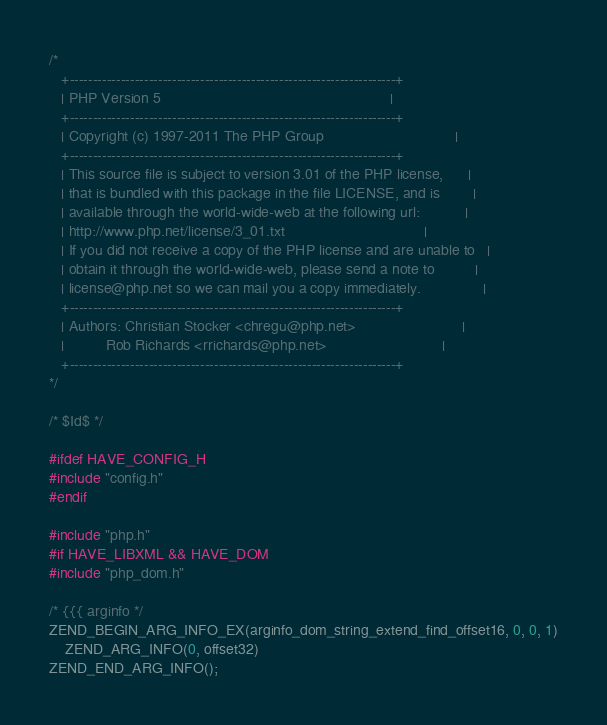<code> <loc_0><loc_0><loc_500><loc_500><_C_>/*
   +----------------------------------------------------------------------+
   | PHP Version 5                                                        |
   +----------------------------------------------------------------------+
   | Copyright (c) 1997-2011 The PHP Group                                |
   +----------------------------------------------------------------------+
   | This source file is subject to version 3.01 of the PHP license,      |
   | that is bundled with this package in the file LICENSE, and is        |
   | available through the world-wide-web at the following url:           |
   | http://www.php.net/license/3_01.txt                                  |
   | If you did not receive a copy of the PHP license and are unable to   |
   | obtain it through the world-wide-web, please send a note to          |
   | license@php.net so we can mail you a copy immediately.               |
   +----------------------------------------------------------------------+
   | Authors: Christian Stocker <chregu@php.net>                          |
   |          Rob Richards <rrichards@php.net>                            |
   +----------------------------------------------------------------------+
*/

/* $Id$ */

#ifdef HAVE_CONFIG_H
#include "config.h"
#endif

#include "php.h"
#if HAVE_LIBXML && HAVE_DOM
#include "php_dom.h"

/* {{{ arginfo */
ZEND_BEGIN_ARG_INFO_EX(arginfo_dom_string_extend_find_offset16, 0, 0, 1)
	ZEND_ARG_INFO(0, offset32)
ZEND_END_ARG_INFO();
</code> 